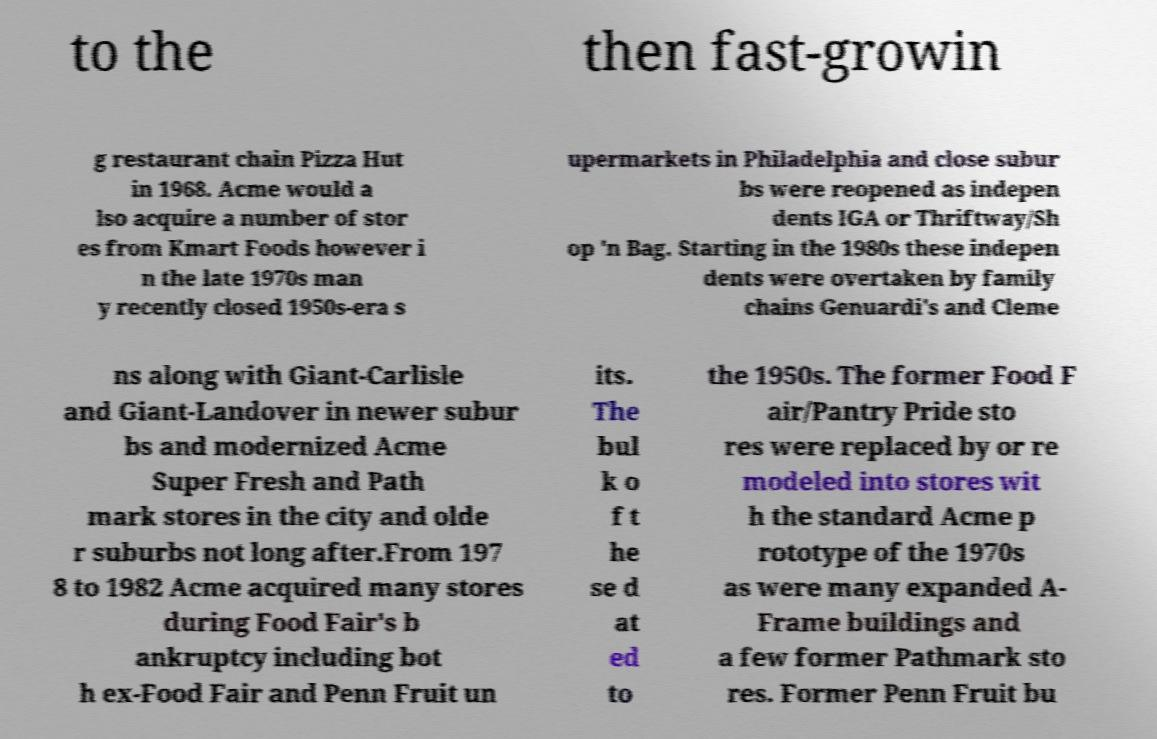Please identify and transcribe the text found in this image. to the then fast-growin g restaurant chain Pizza Hut in 1968. Acme would a lso acquire a number of stor es from Kmart Foods however i n the late 1970s man y recently closed 1950s-era s upermarkets in Philadelphia and close subur bs were reopened as indepen dents IGA or Thriftway/Sh op 'n Bag. Starting in the 1980s these indepen dents were overtaken by family chains Genuardi's and Cleme ns along with Giant-Carlisle and Giant-Landover in newer subur bs and modernized Acme Super Fresh and Path mark stores in the city and olde r suburbs not long after.From 197 8 to 1982 Acme acquired many stores during Food Fair's b ankruptcy including bot h ex-Food Fair and Penn Fruit un its. The bul k o f t he se d at ed to the 1950s. The former Food F air/Pantry Pride sto res were replaced by or re modeled into stores wit h the standard Acme p rototype of the 1970s as were many expanded A- Frame buildings and a few former Pathmark sto res. Former Penn Fruit bu 